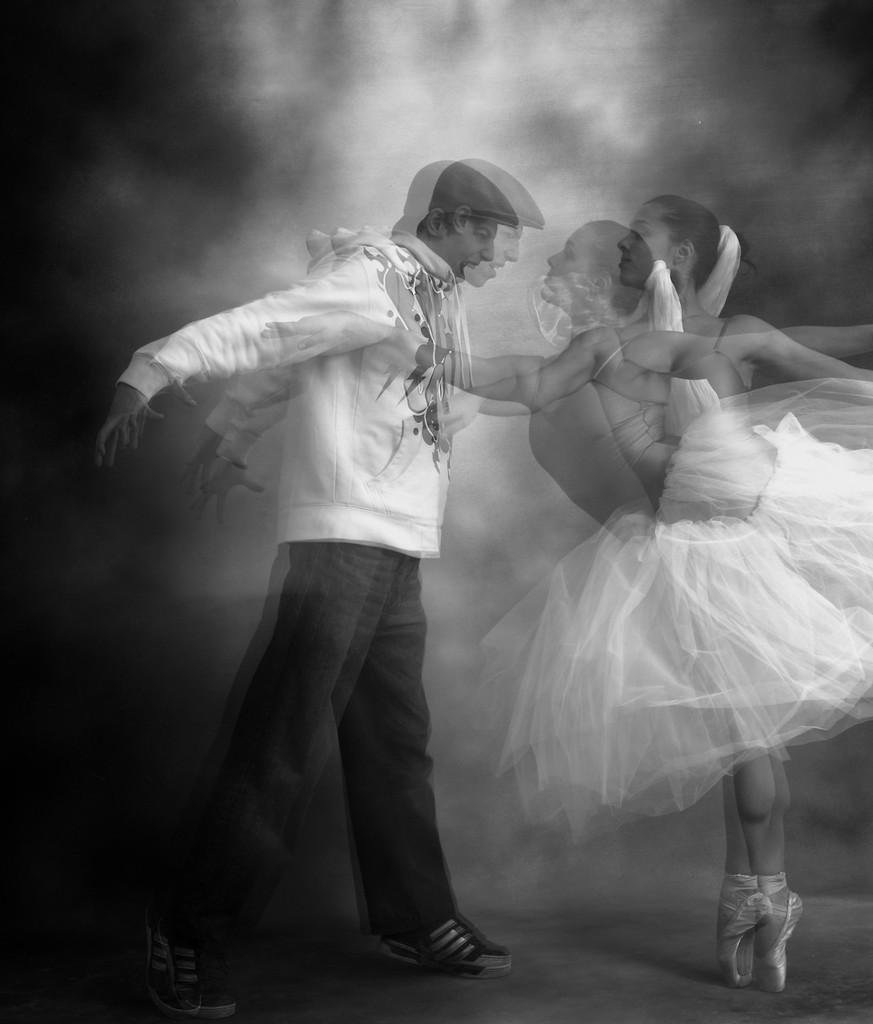Who are the people in the image? There is a man and a lady in the image. What are the positions of the man and the lady in the image? Both the man and the lady are standing. What color is the veil worn by the lady in the image? There is no veil present in the image, so we cannot determine its color. 